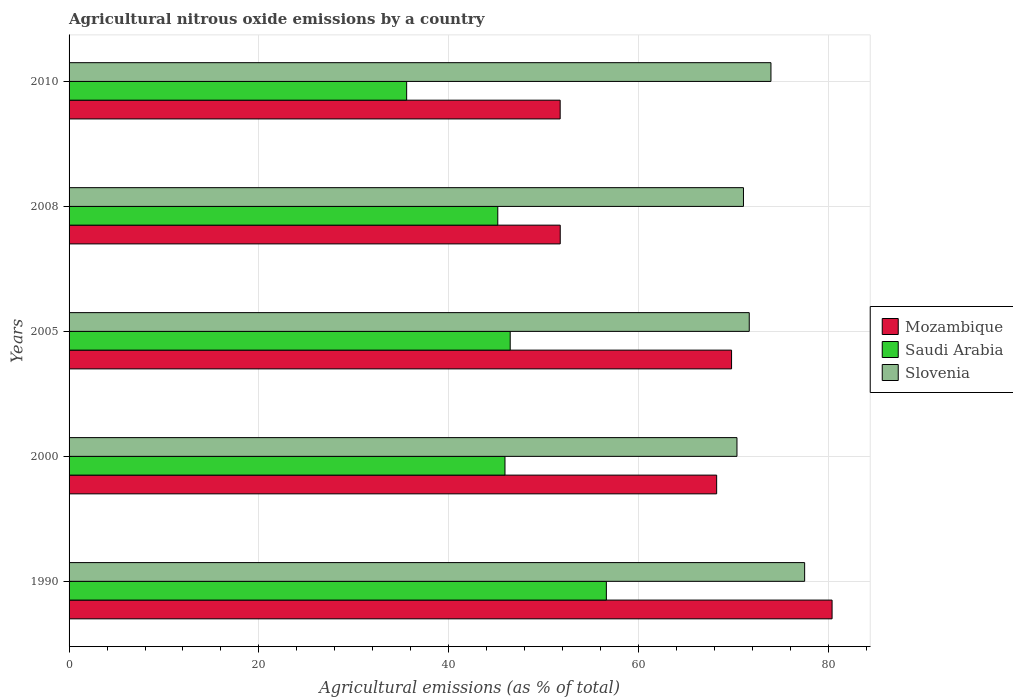How many different coloured bars are there?
Make the answer very short. 3. How many groups of bars are there?
Keep it short and to the point. 5. Are the number of bars per tick equal to the number of legend labels?
Keep it short and to the point. Yes. Are the number of bars on each tick of the Y-axis equal?
Your response must be concise. Yes. What is the label of the 3rd group of bars from the top?
Keep it short and to the point. 2005. What is the amount of agricultural nitrous oxide emitted in Slovenia in 2000?
Ensure brevity in your answer.  70.37. Across all years, what is the maximum amount of agricultural nitrous oxide emitted in Mozambique?
Provide a succinct answer. 80.39. Across all years, what is the minimum amount of agricultural nitrous oxide emitted in Mozambique?
Make the answer very short. 51.74. What is the total amount of agricultural nitrous oxide emitted in Saudi Arabia in the graph?
Your answer should be very brief. 229.76. What is the difference between the amount of agricultural nitrous oxide emitted in Mozambique in 2005 and that in 2008?
Offer a terse response. 18.05. What is the difference between the amount of agricultural nitrous oxide emitted in Slovenia in 2005 and the amount of agricultural nitrous oxide emitted in Mozambique in 2000?
Provide a short and direct response. 3.43. What is the average amount of agricultural nitrous oxide emitted in Slovenia per year?
Provide a succinct answer. 72.91. In the year 2005, what is the difference between the amount of agricultural nitrous oxide emitted in Saudi Arabia and amount of agricultural nitrous oxide emitted in Mozambique?
Make the answer very short. -23.32. In how many years, is the amount of agricultural nitrous oxide emitted in Saudi Arabia greater than 36 %?
Your response must be concise. 4. What is the ratio of the amount of agricultural nitrous oxide emitted in Slovenia in 2000 to that in 2005?
Your answer should be compact. 0.98. Is the amount of agricultural nitrous oxide emitted in Saudi Arabia in 2000 less than that in 2005?
Provide a short and direct response. Yes. What is the difference between the highest and the second highest amount of agricultural nitrous oxide emitted in Mozambique?
Your response must be concise. 10.59. What is the difference between the highest and the lowest amount of agricultural nitrous oxide emitted in Slovenia?
Offer a terse response. 7.13. In how many years, is the amount of agricultural nitrous oxide emitted in Slovenia greater than the average amount of agricultural nitrous oxide emitted in Slovenia taken over all years?
Give a very brief answer. 2. What does the 1st bar from the top in 2010 represents?
Your answer should be compact. Slovenia. What does the 1st bar from the bottom in 2000 represents?
Your answer should be compact. Mozambique. How many bars are there?
Offer a terse response. 15. Are all the bars in the graph horizontal?
Your answer should be very brief. Yes. Are the values on the major ticks of X-axis written in scientific E-notation?
Ensure brevity in your answer.  No. Does the graph contain any zero values?
Give a very brief answer. No. Where does the legend appear in the graph?
Offer a very short reply. Center right. How are the legend labels stacked?
Make the answer very short. Vertical. What is the title of the graph?
Ensure brevity in your answer.  Agricultural nitrous oxide emissions by a country. Does "Cambodia" appear as one of the legend labels in the graph?
Offer a terse response. No. What is the label or title of the X-axis?
Provide a short and direct response. Agricultural emissions (as % of total). What is the Agricultural emissions (as % of total) of Mozambique in 1990?
Your answer should be very brief. 80.39. What is the Agricultural emissions (as % of total) in Saudi Arabia in 1990?
Offer a terse response. 56.61. What is the Agricultural emissions (as % of total) of Slovenia in 1990?
Your response must be concise. 77.5. What is the Agricultural emissions (as % of total) in Mozambique in 2000?
Offer a terse response. 68.23. What is the Agricultural emissions (as % of total) of Saudi Arabia in 2000?
Your answer should be compact. 45.93. What is the Agricultural emissions (as % of total) in Slovenia in 2000?
Ensure brevity in your answer.  70.37. What is the Agricultural emissions (as % of total) of Mozambique in 2005?
Provide a short and direct response. 69.8. What is the Agricultural emissions (as % of total) in Saudi Arabia in 2005?
Ensure brevity in your answer.  46.48. What is the Agricultural emissions (as % of total) of Slovenia in 2005?
Ensure brevity in your answer.  71.67. What is the Agricultural emissions (as % of total) in Mozambique in 2008?
Offer a very short reply. 51.75. What is the Agricultural emissions (as % of total) of Saudi Arabia in 2008?
Keep it short and to the point. 45.17. What is the Agricultural emissions (as % of total) in Slovenia in 2008?
Your answer should be very brief. 71.06. What is the Agricultural emissions (as % of total) in Mozambique in 2010?
Your response must be concise. 51.74. What is the Agricultural emissions (as % of total) in Saudi Arabia in 2010?
Your response must be concise. 35.57. What is the Agricultural emissions (as % of total) in Slovenia in 2010?
Keep it short and to the point. 73.95. Across all years, what is the maximum Agricultural emissions (as % of total) in Mozambique?
Provide a short and direct response. 80.39. Across all years, what is the maximum Agricultural emissions (as % of total) in Saudi Arabia?
Provide a short and direct response. 56.61. Across all years, what is the maximum Agricultural emissions (as % of total) of Slovenia?
Keep it short and to the point. 77.5. Across all years, what is the minimum Agricultural emissions (as % of total) of Mozambique?
Your answer should be compact. 51.74. Across all years, what is the minimum Agricultural emissions (as % of total) of Saudi Arabia?
Provide a succinct answer. 35.57. Across all years, what is the minimum Agricultural emissions (as % of total) in Slovenia?
Offer a terse response. 70.37. What is the total Agricultural emissions (as % of total) of Mozambique in the graph?
Keep it short and to the point. 321.92. What is the total Agricultural emissions (as % of total) of Saudi Arabia in the graph?
Offer a terse response. 229.76. What is the total Agricultural emissions (as % of total) of Slovenia in the graph?
Ensure brevity in your answer.  364.55. What is the difference between the Agricultural emissions (as % of total) in Mozambique in 1990 and that in 2000?
Offer a terse response. 12.16. What is the difference between the Agricultural emissions (as % of total) of Saudi Arabia in 1990 and that in 2000?
Provide a short and direct response. 10.68. What is the difference between the Agricultural emissions (as % of total) of Slovenia in 1990 and that in 2000?
Offer a very short reply. 7.13. What is the difference between the Agricultural emissions (as % of total) of Mozambique in 1990 and that in 2005?
Offer a terse response. 10.59. What is the difference between the Agricultural emissions (as % of total) in Saudi Arabia in 1990 and that in 2005?
Ensure brevity in your answer.  10.13. What is the difference between the Agricultural emissions (as % of total) of Slovenia in 1990 and that in 2005?
Your answer should be compact. 5.84. What is the difference between the Agricultural emissions (as % of total) of Mozambique in 1990 and that in 2008?
Your response must be concise. 28.64. What is the difference between the Agricultural emissions (as % of total) of Saudi Arabia in 1990 and that in 2008?
Offer a very short reply. 11.44. What is the difference between the Agricultural emissions (as % of total) in Slovenia in 1990 and that in 2008?
Keep it short and to the point. 6.45. What is the difference between the Agricultural emissions (as % of total) of Mozambique in 1990 and that in 2010?
Provide a succinct answer. 28.65. What is the difference between the Agricultural emissions (as % of total) of Saudi Arabia in 1990 and that in 2010?
Make the answer very short. 21.04. What is the difference between the Agricultural emissions (as % of total) of Slovenia in 1990 and that in 2010?
Keep it short and to the point. 3.55. What is the difference between the Agricultural emissions (as % of total) in Mozambique in 2000 and that in 2005?
Your answer should be very brief. -1.57. What is the difference between the Agricultural emissions (as % of total) in Saudi Arabia in 2000 and that in 2005?
Keep it short and to the point. -0.55. What is the difference between the Agricultural emissions (as % of total) of Slovenia in 2000 and that in 2005?
Your answer should be compact. -1.29. What is the difference between the Agricultural emissions (as % of total) in Mozambique in 2000 and that in 2008?
Ensure brevity in your answer.  16.48. What is the difference between the Agricultural emissions (as % of total) in Saudi Arabia in 2000 and that in 2008?
Offer a terse response. 0.76. What is the difference between the Agricultural emissions (as % of total) of Slovenia in 2000 and that in 2008?
Your response must be concise. -0.68. What is the difference between the Agricultural emissions (as % of total) of Mozambique in 2000 and that in 2010?
Offer a terse response. 16.49. What is the difference between the Agricultural emissions (as % of total) of Saudi Arabia in 2000 and that in 2010?
Your answer should be compact. 10.36. What is the difference between the Agricultural emissions (as % of total) of Slovenia in 2000 and that in 2010?
Ensure brevity in your answer.  -3.58. What is the difference between the Agricultural emissions (as % of total) of Mozambique in 2005 and that in 2008?
Offer a very short reply. 18.05. What is the difference between the Agricultural emissions (as % of total) in Saudi Arabia in 2005 and that in 2008?
Keep it short and to the point. 1.31. What is the difference between the Agricultural emissions (as % of total) in Slovenia in 2005 and that in 2008?
Provide a short and direct response. 0.61. What is the difference between the Agricultural emissions (as % of total) in Mozambique in 2005 and that in 2010?
Your answer should be very brief. 18.06. What is the difference between the Agricultural emissions (as % of total) of Saudi Arabia in 2005 and that in 2010?
Make the answer very short. 10.91. What is the difference between the Agricultural emissions (as % of total) of Slovenia in 2005 and that in 2010?
Provide a succinct answer. -2.29. What is the difference between the Agricultural emissions (as % of total) in Mozambique in 2008 and that in 2010?
Make the answer very short. 0.01. What is the difference between the Agricultural emissions (as % of total) in Saudi Arabia in 2008 and that in 2010?
Make the answer very short. 9.6. What is the difference between the Agricultural emissions (as % of total) in Slovenia in 2008 and that in 2010?
Offer a terse response. -2.9. What is the difference between the Agricultural emissions (as % of total) of Mozambique in 1990 and the Agricultural emissions (as % of total) of Saudi Arabia in 2000?
Make the answer very short. 34.46. What is the difference between the Agricultural emissions (as % of total) of Mozambique in 1990 and the Agricultural emissions (as % of total) of Slovenia in 2000?
Your answer should be very brief. 10.02. What is the difference between the Agricultural emissions (as % of total) in Saudi Arabia in 1990 and the Agricultural emissions (as % of total) in Slovenia in 2000?
Offer a terse response. -13.76. What is the difference between the Agricultural emissions (as % of total) of Mozambique in 1990 and the Agricultural emissions (as % of total) of Saudi Arabia in 2005?
Keep it short and to the point. 33.91. What is the difference between the Agricultural emissions (as % of total) in Mozambique in 1990 and the Agricultural emissions (as % of total) in Slovenia in 2005?
Keep it short and to the point. 8.73. What is the difference between the Agricultural emissions (as % of total) in Saudi Arabia in 1990 and the Agricultural emissions (as % of total) in Slovenia in 2005?
Your answer should be very brief. -15.05. What is the difference between the Agricultural emissions (as % of total) in Mozambique in 1990 and the Agricultural emissions (as % of total) in Saudi Arabia in 2008?
Ensure brevity in your answer.  35.22. What is the difference between the Agricultural emissions (as % of total) of Mozambique in 1990 and the Agricultural emissions (as % of total) of Slovenia in 2008?
Offer a terse response. 9.34. What is the difference between the Agricultural emissions (as % of total) in Saudi Arabia in 1990 and the Agricultural emissions (as % of total) in Slovenia in 2008?
Offer a terse response. -14.45. What is the difference between the Agricultural emissions (as % of total) in Mozambique in 1990 and the Agricultural emissions (as % of total) in Saudi Arabia in 2010?
Offer a very short reply. 44.82. What is the difference between the Agricultural emissions (as % of total) in Mozambique in 1990 and the Agricultural emissions (as % of total) in Slovenia in 2010?
Provide a short and direct response. 6.44. What is the difference between the Agricultural emissions (as % of total) of Saudi Arabia in 1990 and the Agricultural emissions (as % of total) of Slovenia in 2010?
Make the answer very short. -17.34. What is the difference between the Agricultural emissions (as % of total) of Mozambique in 2000 and the Agricultural emissions (as % of total) of Saudi Arabia in 2005?
Offer a very short reply. 21.75. What is the difference between the Agricultural emissions (as % of total) in Mozambique in 2000 and the Agricultural emissions (as % of total) in Slovenia in 2005?
Your answer should be compact. -3.43. What is the difference between the Agricultural emissions (as % of total) of Saudi Arabia in 2000 and the Agricultural emissions (as % of total) of Slovenia in 2005?
Offer a very short reply. -25.74. What is the difference between the Agricultural emissions (as % of total) in Mozambique in 2000 and the Agricultural emissions (as % of total) in Saudi Arabia in 2008?
Your response must be concise. 23.06. What is the difference between the Agricultural emissions (as % of total) of Mozambique in 2000 and the Agricultural emissions (as % of total) of Slovenia in 2008?
Ensure brevity in your answer.  -2.82. What is the difference between the Agricultural emissions (as % of total) in Saudi Arabia in 2000 and the Agricultural emissions (as % of total) in Slovenia in 2008?
Offer a terse response. -25.13. What is the difference between the Agricultural emissions (as % of total) of Mozambique in 2000 and the Agricultural emissions (as % of total) of Saudi Arabia in 2010?
Your answer should be compact. 32.66. What is the difference between the Agricultural emissions (as % of total) in Mozambique in 2000 and the Agricultural emissions (as % of total) in Slovenia in 2010?
Ensure brevity in your answer.  -5.72. What is the difference between the Agricultural emissions (as % of total) in Saudi Arabia in 2000 and the Agricultural emissions (as % of total) in Slovenia in 2010?
Offer a very short reply. -28.02. What is the difference between the Agricultural emissions (as % of total) in Mozambique in 2005 and the Agricultural emissions (as % of total) in Saudi Arabia in 2008?
Your answer should be very brief. 24.63. What is the difference between the Agricultural emissions (as % of total) in Mozambique in 2005 and the Agricultural emissions (as % of total) in Slovenia in 2008?
Provide a short and direct response. -1.26. What is the difference between the Agricultural emissions (as % of total) in Saudi Arabia in 2005 and the Agricultural emissions (as % of total) in Slovenia in 2008?
Offer a very short reply. -24.58. What is the difference between the Agricultural emissions (as % of total) in Mozambique in 2005 and the Agricultural emissions (as % of total) in Saudi Arabia in 2010?
Offer a terse response. 34.23. What is the difference between the Agricultural emissions (as % of total) in Mozambique in 2005 and the Agricultural emissions (as % of total) in Slovenia in 2010?
Make the answer very short. -4.15. What is the difference between the Agricultural emissions (as % of total) in Saudi Arabia in 2005 and the Agricultural emissions (as % of total) in Slovenia in 2010?
Make the answer very short. -27.47. What is the difference between the Agricultural emissions (as % of total) of Mozambique in 2008 and the Agricultural emissions (as % of total) of Saudi Arabia in 2010?
Keep it short and to the point. 16.18. What is the difference between the Agricultural emissions (as % of total) of Mozambique in 2008 and the Agricultural emissions (as % of total) of Slovenia in 2010?
Your answer should be compact. -22.2. What is the difference between the Agricultural emissions (as % of total) of Saudi Arabia in 2008 and the Agricultural emissions (as % of total) of Slovenia in 2010?
Your answer should be compact. -28.78. What is the average Agricultural emissions (as % of total) of Mozambique per year?
Keep it short and to the point. 64.38. What is the average Agricultural emissions (as % of total) of Saudi Arabia per year?
Provide a succinct answer. 45.95. What is the average Agricultural emissions (as % of total) of Slovenia per year?
Your response must be concise. 72.91. In the year 1990, what is the difference between the Agricultural emissions (as % of total) in Mozambique and Agricultural emissions (as % of total) in Saudi Arabia?
Your answer should be very brief. 23.78. In the year 1990, what is the difference between the Agricultural emissions (as % of total) in Mozambique and Agricultural emissions (as % of total) in Slovenia?
Your answer should be very brief. 2.89. In the year 1990, what is the difference between the Agricultural emissions (as % of total) of Saudi Arabia and Agricultural emissions (as % of total) of Slovenia?
Provide a short and direct response. -20.89. In the year 2000, what is the difference between the Agricultural emissions (as % of total) of Mozambique and Agricultural emissions (as % of total) of Saudi Arabia?
Make the answer very short. 22.3. In the year 2000, what is the difference between the Agricultural emissions (as % of total) of Mozambique and Agricultural emissions (as % of total) of Slovenia?
Give a very brief answer. -2.14. In the year 2000, what is the difference between the Agricultural emissions (as % of total) of Saudi Arabia and Agricultural emissions (as % of total) of Slovenia?
Your answer should be compact. -24.44. In the year 2005, what is the difference between the Agricultural emissions (as % of total) in Mozambique and Agricultural emissions (as % of total) in Saudi Arabia?
Make the answer very short. 23.32. In the year 2005, what is the difference between the Agricultural emissions (as % of total) in Mozambique and Agricultural emissions (as % of total) in Slovenia?
Your response must be concise. -1.86. In the year 2005, what is the difference between the Agricultural emissions (as % of total) of Saudi Arabia and Agricultural emissions (as % of total) of Slovenia?
Keep it short and to the point. -25.19. In the year 2008, what is the difference between the Agricultural emissions (as % of total) of Mozambique and Agricultural emissions (as % of total) of Saudi Arabia?
Offer a terse response. 6.58. In the year 2008, what is the difference between the Agricultural emissions (as % of total) of Mozambique and Agricultural emissions (as % of total) of Slovenia?
Offer a very short reply. -19.31. In the year 2008, what is the difference between the Agricultural emissions (as % of total) of Saudi Arabia and Agricultural emissions (as % of total) of Slovenia?
Offer a very short reply. -25.89. In the year 2010, what is the difference between the Agricultural emissions (as % of total) in Mozambique and Agricultural emissions (as % of total) in Saudi Arabia?
Make the answer very short. 16.17. In the year 2010, what is the difference between the Agricultural emissions (as % of total) in Mozambique and Agricultural emissions (as % of total) in Slovenia?
Give a very brief answer. -22.21. In the year 2010, what is the difference between the Agricultural emissions (as % of total) of Saudi Arabia and Agricultural emissions (as % of total) of Slovenia?
Your answer should be very brief. -38.38. What is the ratio of the Agricultural emissions (as % of total) of Mozambique in 1990 to that in 2000?
Offer a very short reply. 1.18. What is the ratio of the Agricultural emissions (as % of total) in Saudi Arabia in 1990 to that in 2000?
Offer a terse response. 1.23. What is the ratio of the Agricultural emissions (as % of total) in Slovenia in 1990 to that in 2000?
Your answer should be very brief. 1.1. What is the ratio of the Agricultural emissions (as % of total) of Mozambique in 1990 to that in 2005?
Offer a terse response. 1.15. What is the ratio of the Agricultural emissions (as % of total) of Saudi Arabia in 1990 to that in 2005?
Give a very brief answer. 1.22. What is the ratio of the Agricultural emissions (as % of total) of Slovenia in 1990 to that in 2005?
Your answer should be compact. 1.08. What is the ratio of the Agricultural emissions (as % of total) of Mozambique in 1990 to that in 2008?
Your answer should be very brief. 1.55. What is the ratio of the Agricultural emissions (as % of total) in Saudi Arabia in 1990 to that in 2008?
Provide a succinct answer. 1.25. What is the ratio of the Agricultural emissions (as % of total) in Slovenia in 1990 to that in 2008?
Provide a succinct answer. 1.09. What is the ratio of the Agricultural emissions (as % of total) in Mozambique in 1990 to that in 2010?
Your response must be concise. 1.55. What is the ratio of the Agricultural emissions (as % of total) in Saudi Arabia in 1990 to that in 2010?
Offer a very short reply. 1.59. What is the ratio of the Agricultural emissions (as % of total) of Slovenia in 1990 to that in 2010?
Keep it short and to the point. 1.05. What is the ratio of the Agricultural emissions (as % of total) of Mozambique in 2000 to that in 2005?
Provide a short and direct response. 0.98. What is the ratio of the Agricultural emissions (as % of total) of Slovenia in 2000 to that in 2005?
Provide a short and direct response. 0.98. What is the ratio of the Agricultural emissions (as % of total) in Mozambique in 2000 to that in 2008?
Offer a very short reply. 1.32. What is the ratio of the Agricultural emissions (as % of total) in Saudi Arabia in 2000 to that in 2008?
Your response must be concise. 1.02. What is the ratio of the Agricultural emissions (as % of total) of Slovenia in 2000 to that in 2008?
Keep it short and to the point. 0.99. What is the ratio of the Agricultural emissions (as % of total) of Mozambique in 2000 to that in 2010?
Give a very brief answer. 1.32. What is the ratio of the Agricultural emissions (as % of total) of Saudi Arabia in 2000 to that in 2010?
Provide a short and direct response. 1.29. What is the ratio of the Agricultural emissions (as % of total) of Slovenia in 2000 to that in 2010?
Make the answer very short. 0.95. What is the ratio of the Agricultural emissions (as % of total) in Mozambique in 2005 to that in 2008?
Provide a succinct answer. 1.35. What is the ratio of the Agricultural emissions (as % of total) of Saudi Arabia in 2005 to that in 2008?
Provide a short and direct response. 1.03. What is the ratio of the Agricultural emissions (as % of total) in Slovenia in 2005 to that in 2008?
Keep it short and to the point. 1.01. What is the ratio of the Agricultural emissions (as % of total) of Mozambique in 2005 to that in 2010?
Your answer should be compact. 1.35. What is the ratio of the Agricultural emissions (as % of total) of Saudi Arabia in 2005 to that in 2010?
Offer a terse response. 1.31. What is the ratio of the Agricultural emissions (as % of total) in Slovenia in 2005 to that in 2010?
Your response must be concise. 0.97. What is the ratio of the Agricultural emissions (as % of total) in Mozambique in 2008 to that in 2010?
Make the answer very short. 1. What is the ratio of the Agricultural emissions (as % of total) of Saudi Arabia in 2008 to that in 2010?
Offer a terse response. 1.27. What is the ratio of the Agricultural emissions (as % of total) in Slovenia in 2008 to that in 2010?
Provide a short and direct response. 0.96. What is the difference between the highest and the second highest Agricultural emissions (as % of total) of Mozambique?
Ensure brevity in your answer.  10.59. What is the difference between the highest and the second highest Agricultural emissions (as % of total) in Saudi Arabia?
Give a very brief answer. 10.13. What is the difference between the highest and the second highest Agricultural emissions (as % of total) in Slovenia?
Your response must be concise. 3.55. What is the difference between the highest and the lowest Agricultural emissions (as % of total) in Mozambique?
Provide a succinct answer. 28.65. What is the difference between the highest and the lowest Agricultural emissions (as % of total) of Saudi Arabia?
Give a very brief answer. 21.04. What is the difference between the highest and the lowest Agricultural emissions (as % of total) of Slovenia?
Keep it short and to the point. 7.13. 